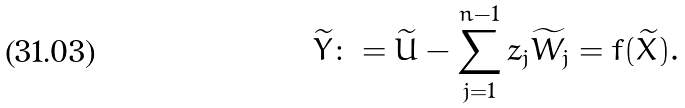<formula> <loc_0><loc_0><loc_500><loc_500>\widetilde { Y } \colon = \widetilde { U } - \sum _ { j = 1 } ^ { n - 1 } z _ { j } \widetilde { W } _ { j } = f ( \widetilde { X } ) .</formula> 